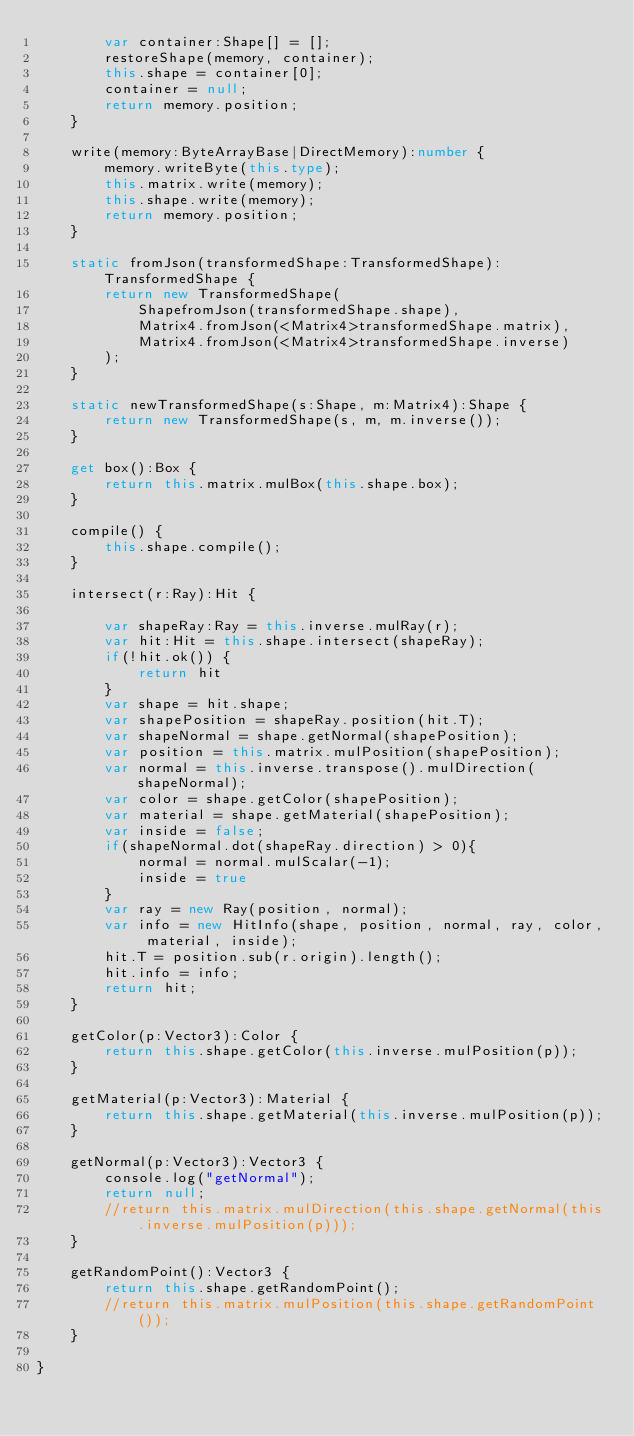Convert code to text. <code><loc_0><loc_0><loc_500><loc_500><_TypeScript_>        var container:Shape[] = [];
        restoreShape(memory, container);
        this.shape = container[0];
        container = null;
        return memory.position;
    }

    write(memory:ByteArrayBase|DirectMemory):number {
        memory.writeByte(this.type);
        this.matrix.write(memory);
        this.shape.write(memory);
        return memory.position;
    }

    static fromJson(transformedShape:TransformedShape):TransformedShape {
        return new TransformedShape(
            ShapefromJson(transformedShape.shape),
            Matrix4.fromJson(<Matrix4>transformedShape.matrix),
            Matrix4.fromJson(<Matrix4>transformedShape.inverse)
        );
    }

    static newTransformedShape(s:Shape, m:Matrix4):Shape {
        return new TransformedShape(s, m, m.inverse());
    }

    get box():Box {
        return this.matrix.mulBox(this.shape.box);
    }

    compile() {
        this.shape.compile();
    }

    intersect(r:Ray):Hit {

        var shapeRay:Ray = this.inverse.mulRay(r);
        var hit:Hit = this.shape.intersect(shapeRay);
        if(!hit.ok()) {
            return hit
        }
        var shape = hit.shape;
        var shapePosition = shapeRay.position(hit.T);
        var shapeNormal = shape.getNormal(shapePosition);
        var position = this.matrix.mulPosition(shapePosition);
        var normal = this.inverse.transpose().mulDirection(shapeNormal);
        var color = shape.getColor(shapePosition);
        var material = shape.getMaterial(shapePosition);
        var inside = false;
        if(shapeNormal.dot(shapeRay.direction) > 0){
            normal = normal.mulScalar(-1);
            inside = true
        }
        var ray = new Ray(position, normal);
        var info = new HitInfo(shape, position, normal, ray, color, material, inside);
        hit.T = position.sub(r.origin).length();
        hit.info = info;
        return hit;
    }

    getColor(p:Vector3):Color {
        return this.shape.getColor(this.inverse.mulPosition(p));
    }

    getMaterial(p:Vector3):Material {
        return this.shape.getMaterial(this.inverse.mulPosition(p));
    }

    getNormal(p:Vector3):Vector3 {
        console.log("getNormal");
        return null;
        //return this.matrix.mulDirection(this.shape.getNormal(this.inverse.mulPosition(p)));
    }

    getRandomPoint():Vector3 {
        return this.shape.getRandomPoint();
        //return this.matrix.mulPosition(this.shape.getRandomPoint());
    }

}
</code> 